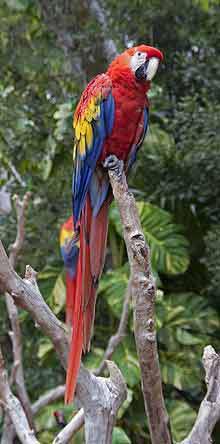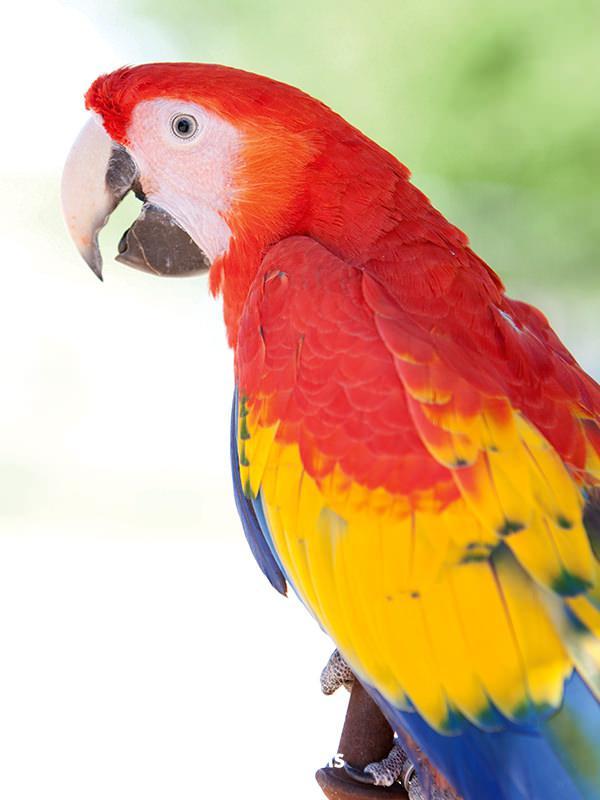The first image is the image on the left, the second image is the image on the right. Given the left and right images, does the statement "There are exactly two birds in the image on the right." hold true? Answer yes or no. No. The first image is the image on the left, the second image is the image on the right. For the images shown, is this caption "There are exactly two birds in the image on the right." true? Answer yes or no. No. The first image is the image on the left, the second image is the image on the right. Given the left and right images, does the statement "In one image, two parrots are sitting together, but facing different directions." hold true? Answer yes or no. No. The first image is the image on the left, the second image is the image on the right. Evaluate the accuracy of this statement regarding the images: "There are only two birds and neither of them is flying.". Is it true? Answer yes or no. Yes. 